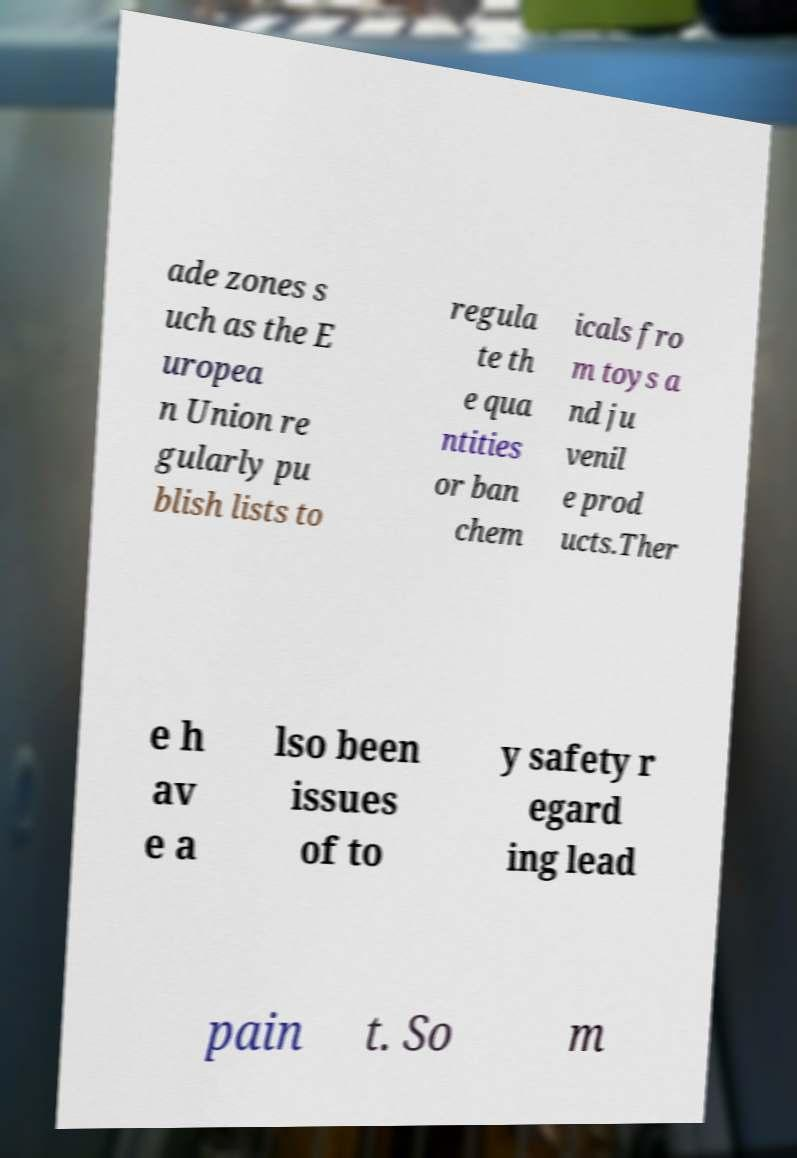Could you extract and type out the text from this image? ade zones s uch as the E uropea n Union re gularly pu blish lists to regula te th e qua ntities or ban chem icals fro m toys a nd ju venil e prod ucts.Ther e h av e a lso been issues of to y safety r egard ing lead pain t. So m 